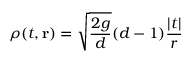Convert formula to latex. <formula><loc_0><loc_0><loc_500><loc_500>\rho ( t , { r } ) = \sqrt { \frac { 2 g } { d } } ( d - 1 ) { \frac { | t | } { r } }</formula> 